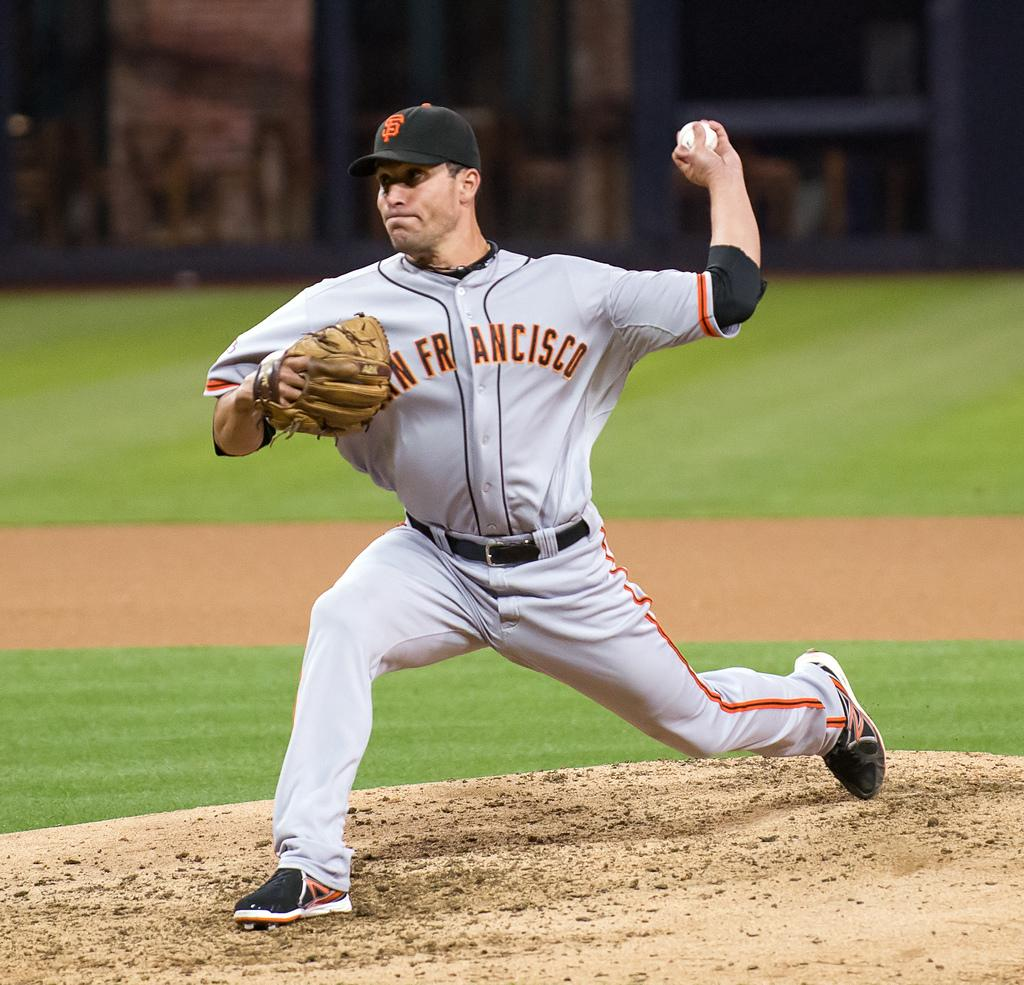What is the main subject of the image? There is a person in the image. What is the person doing in the image? The person is throwing a ball. What equipment is the person using while throwing the ball? The person is wearing a baseball glove on one hand. How is the background of the image? The background of the person is blurred. What type of hook can be seen in the image? There is no hook present in the image. What is the condition of the person in the image? The image does not provide information about the person's condition. 